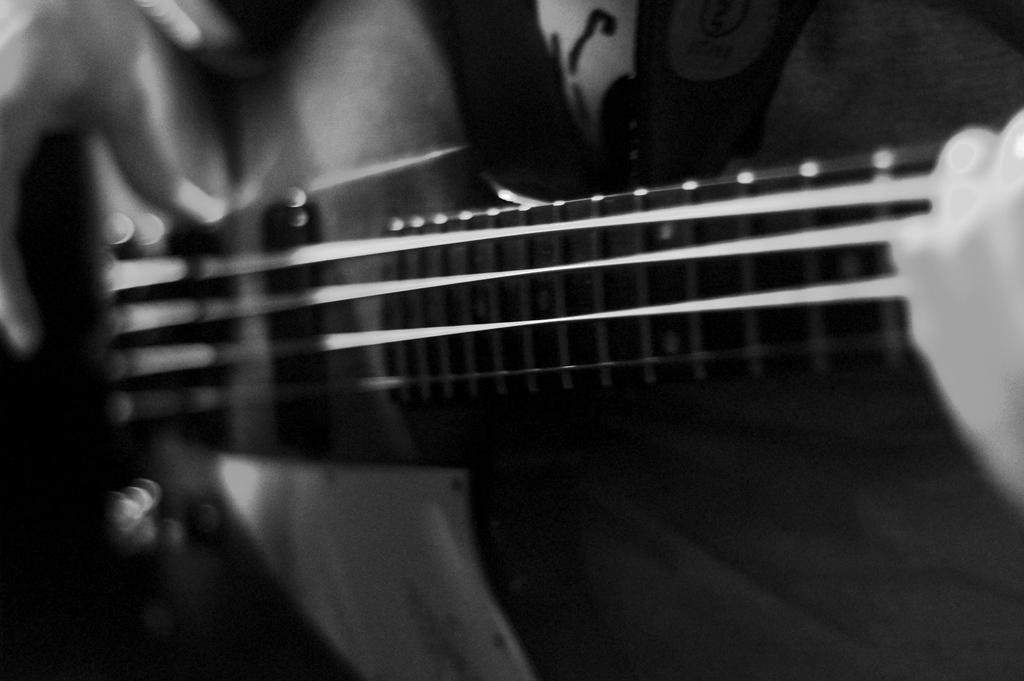What is the color scheme of the photograph? The photograph is black and white. What is the main subject of the photograph? The photograph depicts a guitar. What feature of the guitar is visible in the image? The guitar has strings. Can you identify any part of a person in the photograph? Yes, a part of a person's hand is visible on the guitar. What type of bird can be seen perched on the guitar in the image? There are no birds present in the image; it features a guitar with a person's hand on it. How many facts can you count in the image? The image itself does not contain any facts, as it is a photograph of a guitar. 